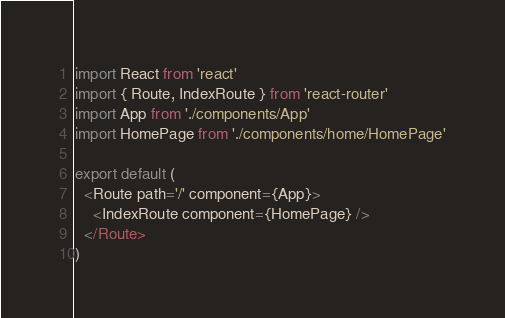<code> <loc_0><loc_0><loc_500><loc_500><_JavaScript_>import React from 'react'
import { Route, IndexRoute } from 'react-router'
import App from './components/App'
import HomePage from './components/home/HomePage'

export default (
  <Route path='/' component={App}>
    <IndexRoute component={HomePage} />
  </Route>
)
</code> 